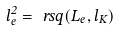<formula> <loc_0><loc_0><loc_500><loc_500>l _ { e } ^ { 2 } = \ r s q ( L _ { e } , l _ { K } )</formula> 